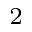Convert formula to latex. <formula><loc_0><loc_0><loc_500><loc_500>^ { 2 }</formula> 